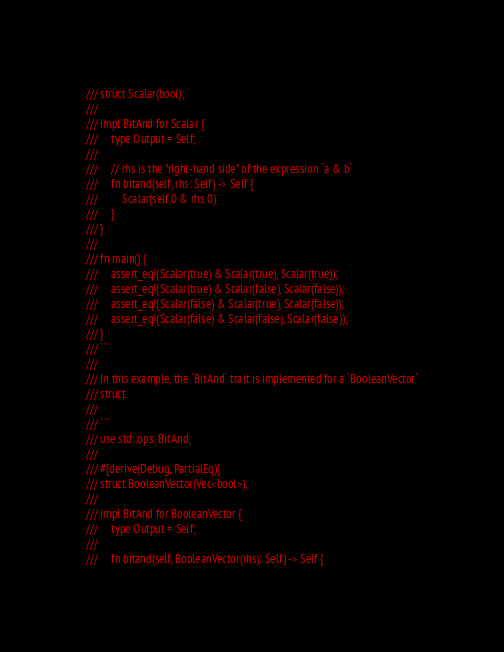Convert code to text. <code><loc_0><loc_0><loc_500><loc_500><_Rust_>/// struct Scalar(bool);
///
/// impl BitAnd for Scalar {
///     type Output = Self;
///
///     // rhs is the "right-hand side" of the expression `a & b`
///     fn bitand(self, rhs: Self) -> Self {
///         Scalar(self.0 & rhs.0)
///     }
/// }
///
/// fn main() {
///     assert_eq!(Scalar(true) & Scalar(true), Scalar(true));
///     assert_eq!(Scalar(true) & Scalar(false), Scalar(false));
///     assert_eq!(Scalar(false) & Scalar(true), Scalar(false));
///     assert_eq!(Scalar(false) & Scalar(false), Scalar(false));
/// }
/// ```
///
/// In this example, the `BitAnd` trait is implemented for a `BooleanVector`
/// struct.
///
/// ```
/// use std::ops::BitAnd;
///
/// #[derive(Debug, PartialEq)]
/// struct BooleanVector(Vec<bool>);
///
/// impl BitAnd for BooleanVector {
///     type Output = Self;
///
///     fn bitand(self, BooleanVector(rhs): Self) -> Self {</code> 